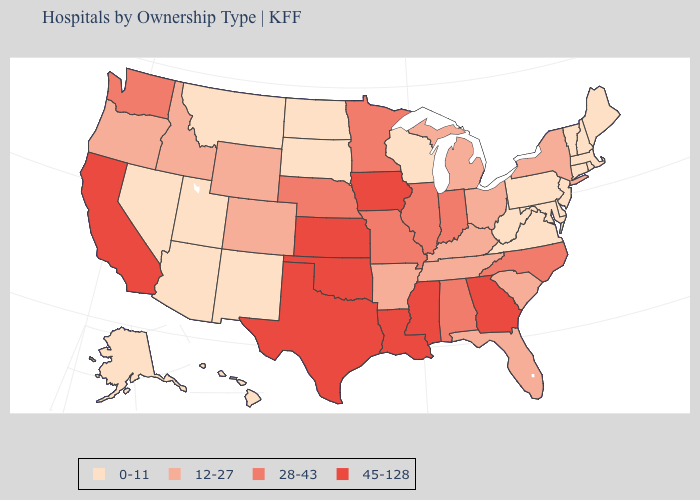What is the lowest value in states that border Nebraska?
Answer briefly. 0-11. How many symbols are there in the legend?
Answer briefly. 4. What is the value of West Virginia?
Concise answer only. 0-11. What is the lowest value in the USA?
Be succinct. 0-11. Name the states that have a value in the range 28-43?
Keep it brief. Alabama, Illinois, Indiana, Minnesota, Missouri, Nebraska, North Carolina, Washington. What is the highest value in the USA?
Answer briefly. 45-128. Is the legend a continuous bar?
Be succinct. No. Does Utah have a lower value than Maine?
Give a very brief answer. No. Name the states that have a value in the range 28-43?
Quick response, please. Alabama, Illinois, Indiana, Minnesota, Missouri, Nebraska, North Carolina, Washington. Name the states that have a value in the range 28-43?
Write a very short answer. Alabama, Illinois, Indiana, Minnesota, Missouri, Nebraska, North Carolina, Washington. What is the value of Missouri?
Be succinct. 28-43. Among the states that border Alabama , which have the lowest value?
Quick response, please. Florida, Tennessee. Does Washington have the lowest value in the West?
Short answer required. No. Name the states that have a value in the range 45-128?
Give a very brief answer. California, Georgia, Iowa, Kansas, Louisiana, Mississippi, Oklahoma, Texas. Name the states that have a value in the range 0-11?
Be succinct. Alaska, Arizona, Connecticut, Delaware, Hawaii, Maine, Maryland, Massachusetts, Montana, Nevada, New Hampshire, New Jersey, New Mexico, North Dakota, Pennsylvania, Rhode Island, South Dakota, Utah, Vermont, Virginia, West Virginia, Wisconsin. 